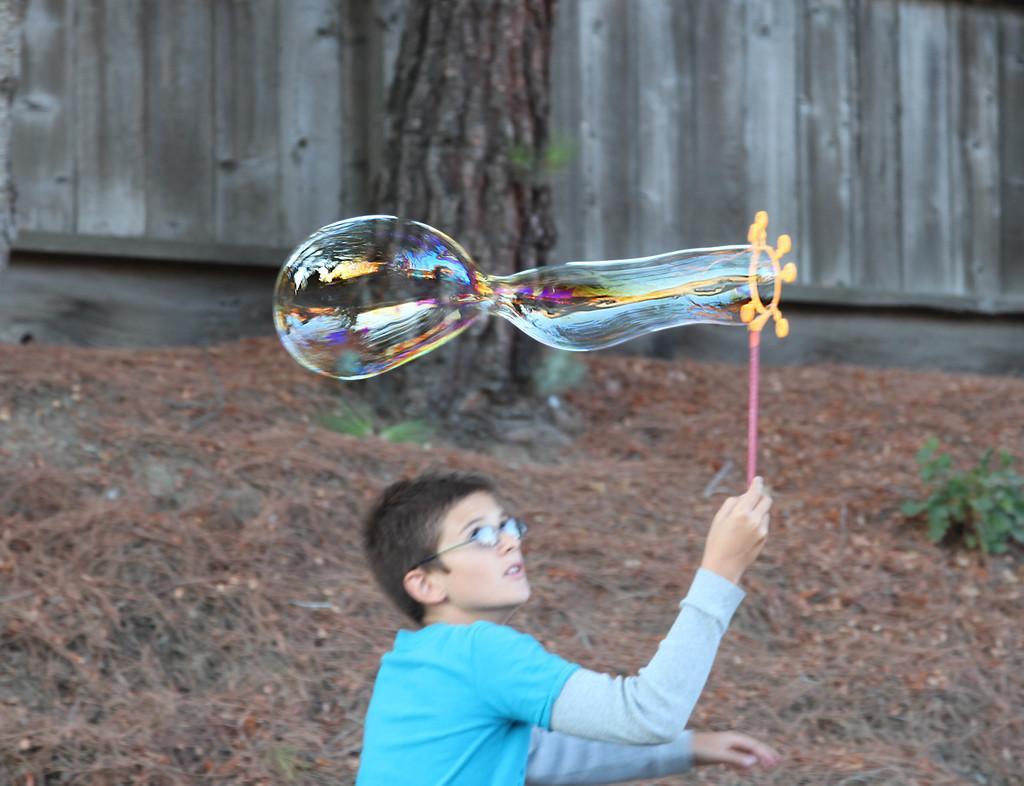Can you describe this image briefly? In this image I can see a person standing and holding some object which is in pink color and the person is wearing blue color shirt. Background I can see a bubble, plants in green color, a trunk and the wooden surface. 